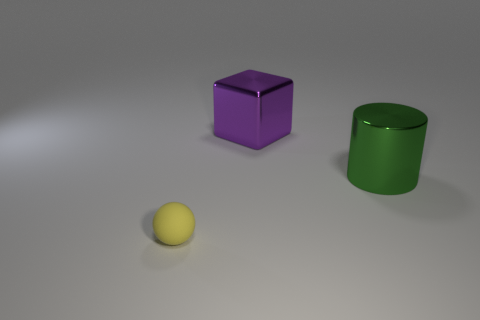Subtract all yellow balls. How many purple cylinders are left? 0 Subtract all small gray rubber balls. Subtract all green cylinders. How many objects are left? 2 Add 3 rubber balls. How many rubber balls are left? 4 Add 2 blue rubber cylinders. How many blue rubber cylinders exist? 2 Add 1 gray matte cylinders. How many objects exist? 4 Subtract 0 purple cylinders. How many objects are left? 3 Subtract all cubes. How many objects are left? 2 Subtract all brown blocks. Subtract all brown spheres. How many blocks are left? 1 